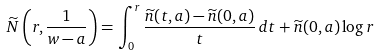<formula> <loc_0><loc_0><loc_500><loc_500>\widetilde { N } \left ( r , \frac { 1 } { w - a } \right ) = \int _ { 0 } ^ { r } \frac { \widetilde { n } ( t , a ) - \widetilde { n } ( 0 , a ) } { t } \, d t + \widetilde { n } ( 0 , a ) \log r</formula> 